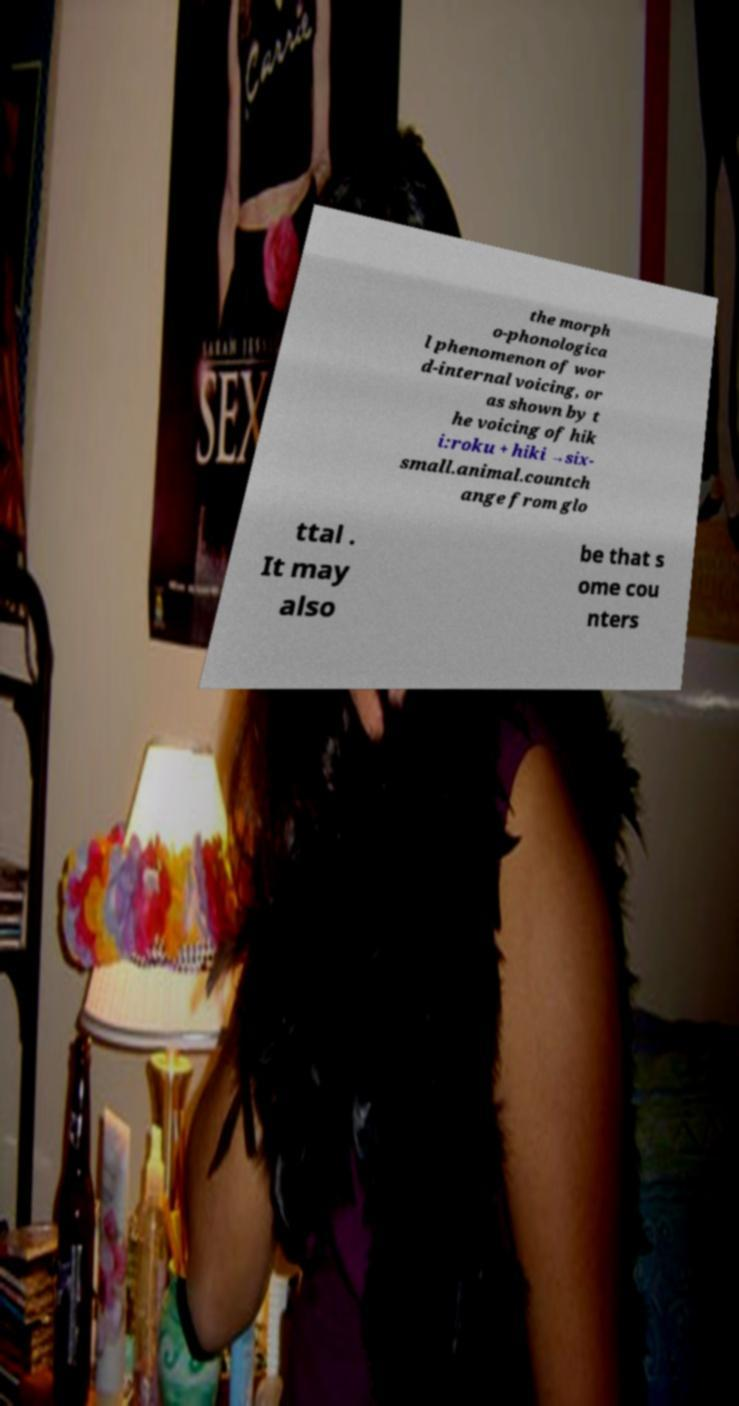Please read and relay the text visible in this image. What does it say? the morph o-phonologica l phenomenon of wor d-internal voicing, or as shown by t he voicing of hik i:roku + hiki →six- small.animal.countch ange from glo ttal . It may also be that s ome cou nters 